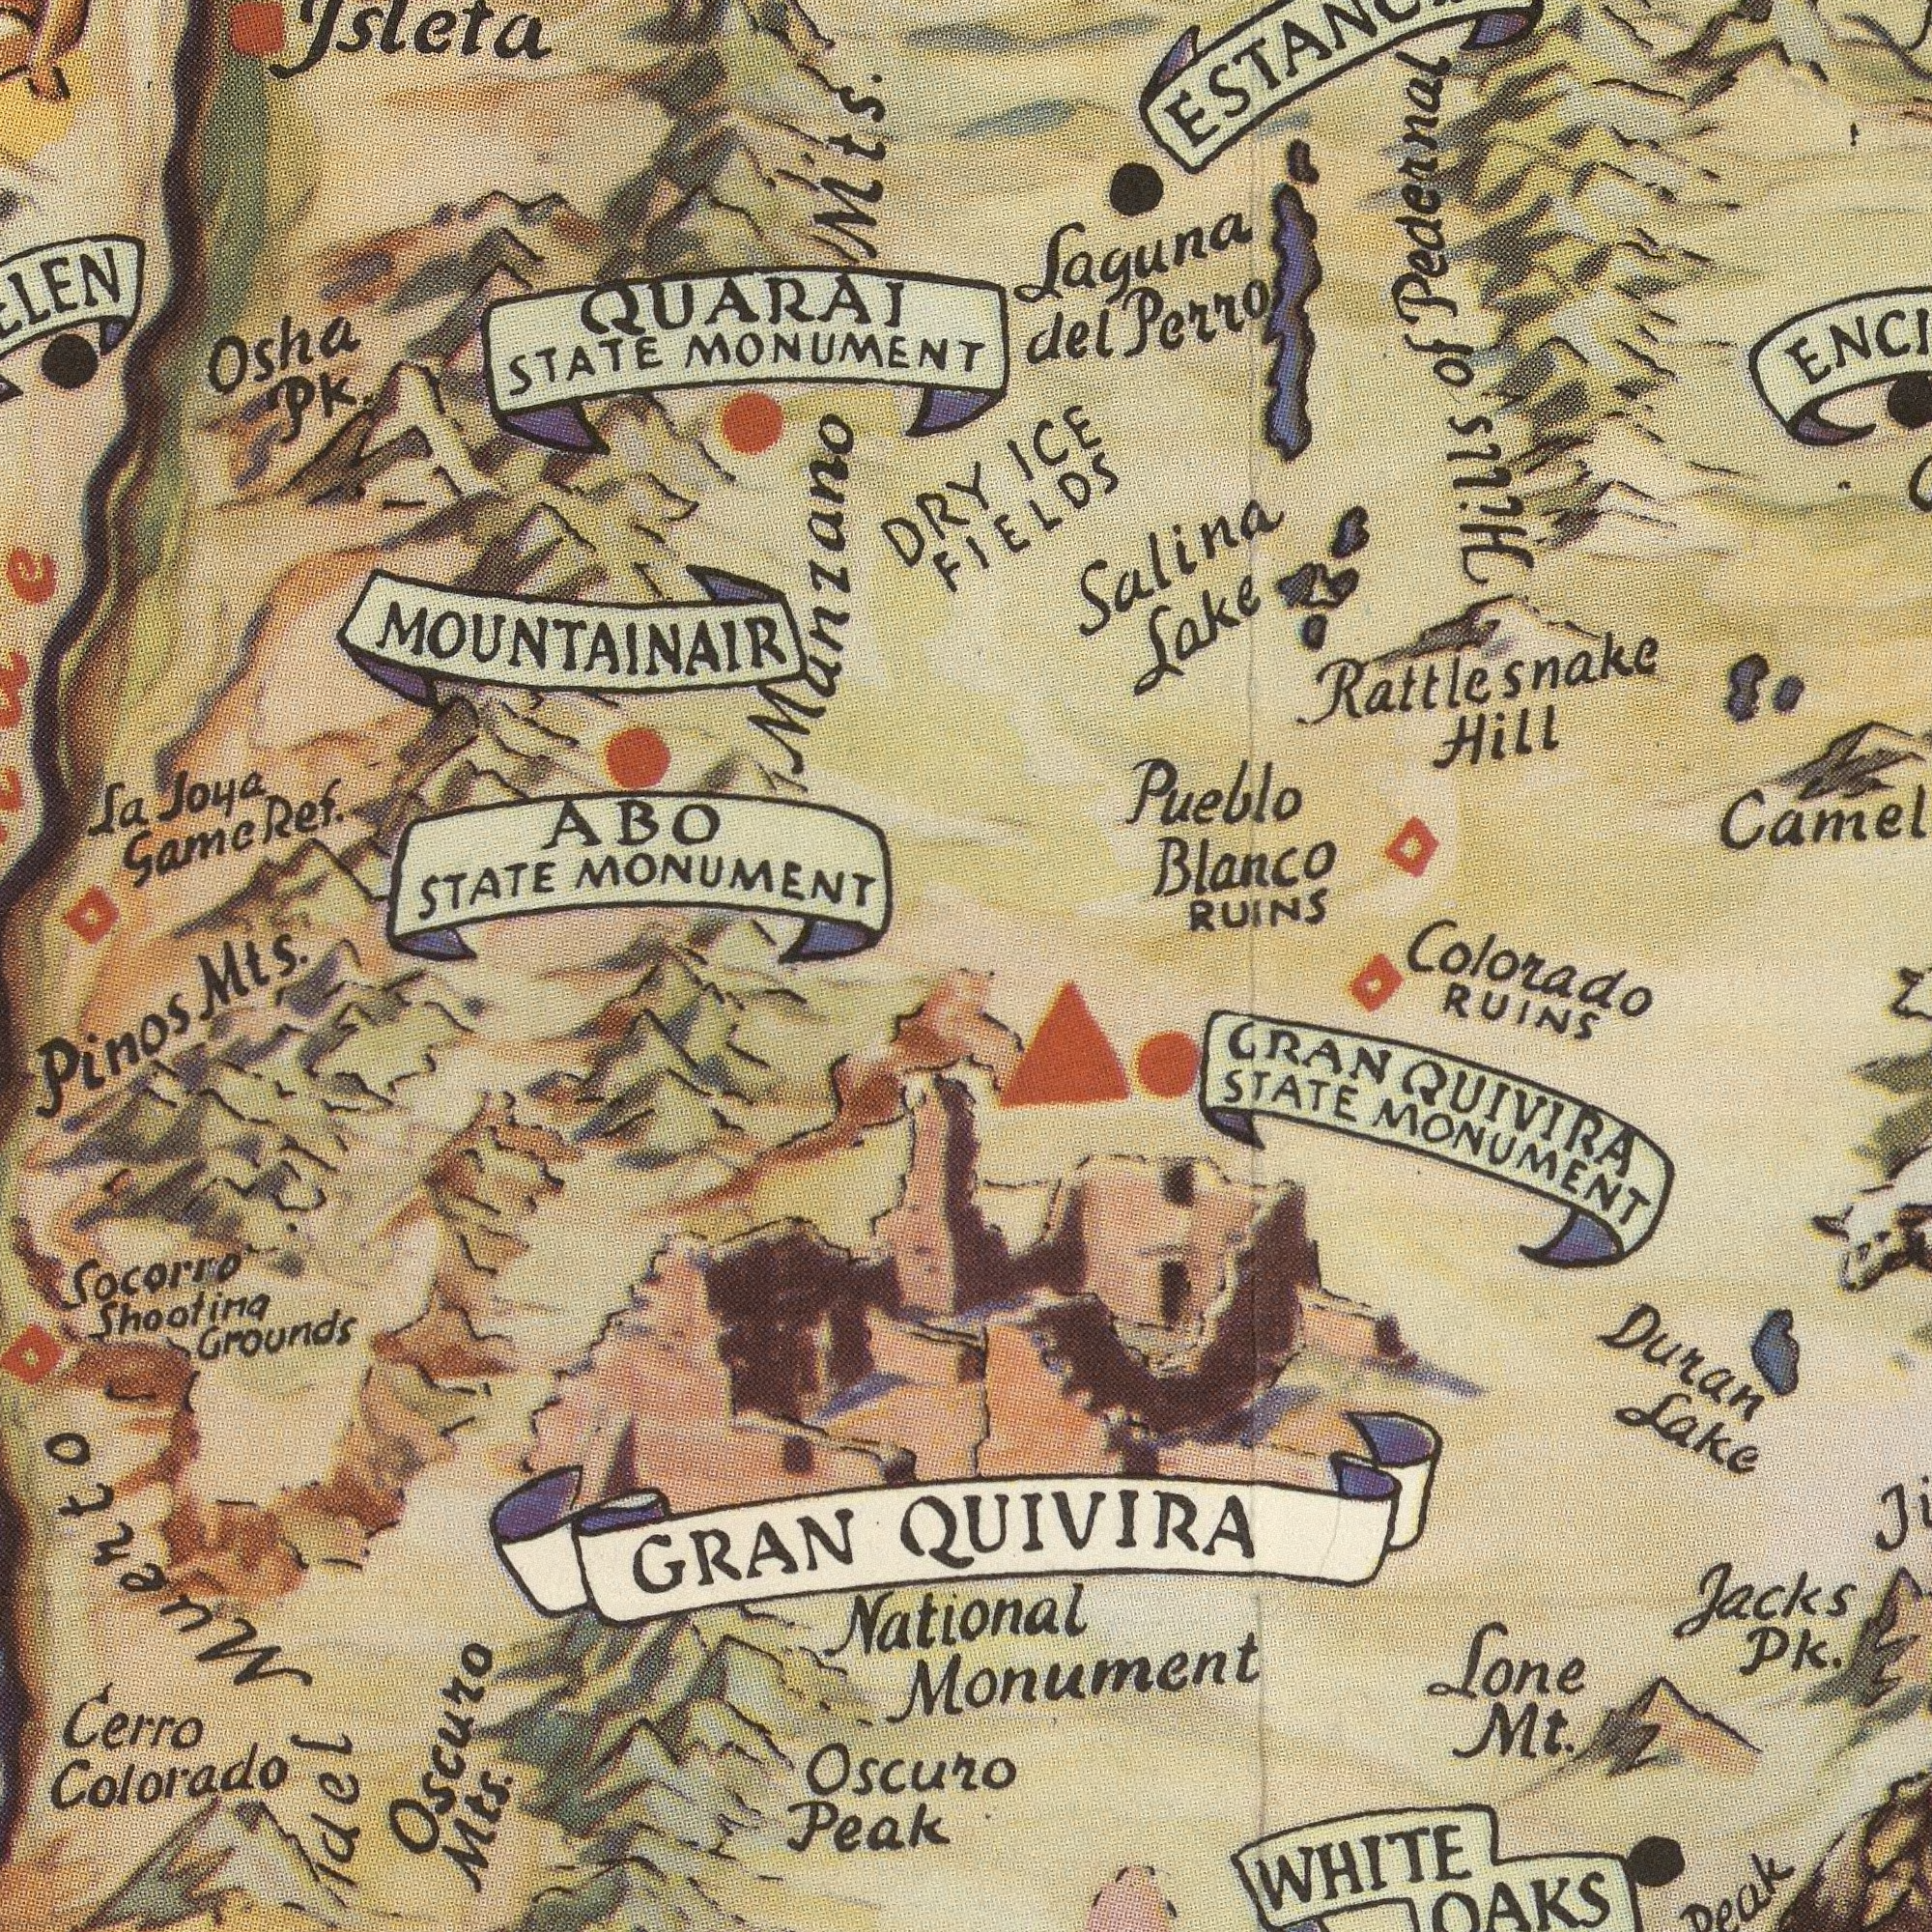What text is visible in the upper-left corner? STATE MONUMENT Game QUARAI Pk. STATE MONUMENT Joya La Ref. ABO MOUNTAINAIR Osha Mts. Munzano Mts. What text is visible in the upper-right corner? DRY Pueblo Blanco RUINS Perro FIELDS ICE Lake del Laguna Pedennal Hill Salina Rattlesnake Colorado Hills of What text appears in the bottom-left area of the image? Colorado Grounds Peak Socorro GRAN Mts. Shootima Cerro Oscuro Pinos Oscuro Idel Muerto What text is shown in the bottom-right quadrant? National RUINS Duran STATE Mt. Jacks Lone QUIVIRA Lake WHITE MONUMENT Pk. Monument GRAN QUIVIRA 